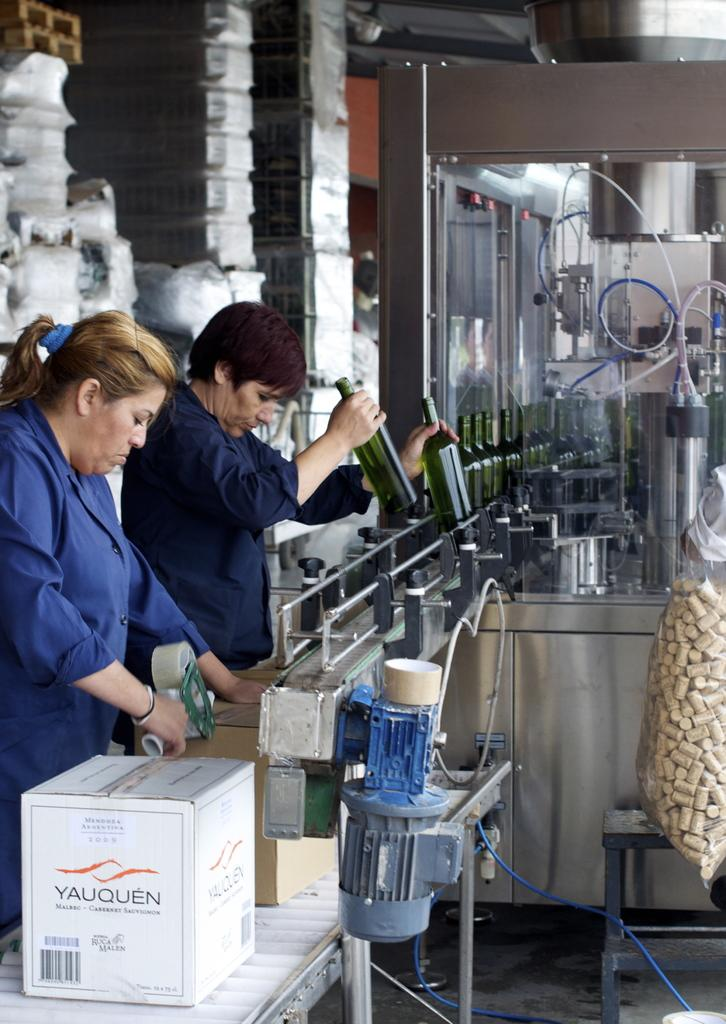How many people are present in the image? There are two ladies in the image. What are the ladies doing in the image? One of the ladies is holding bottles, and the other lady is packing boxes. What can be seen in the background of the image? There are machines in the background of the image. What type of nail is being used by the lady packing boxes in the image? There is no nail visible in the image, and the lady packing boxes is not using any nail. 